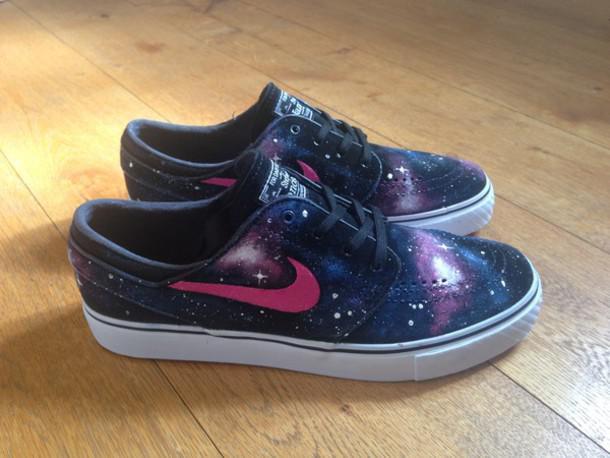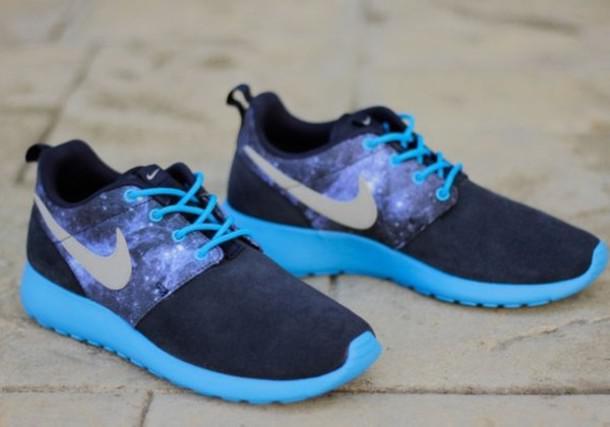The first image is the image on the left, the second image is the image on the right. Considering the images on both sides, is "One pair of casual shoes has a small black tag sticking up from the back of each shoe." valid? Answer yes or no. Yes. 